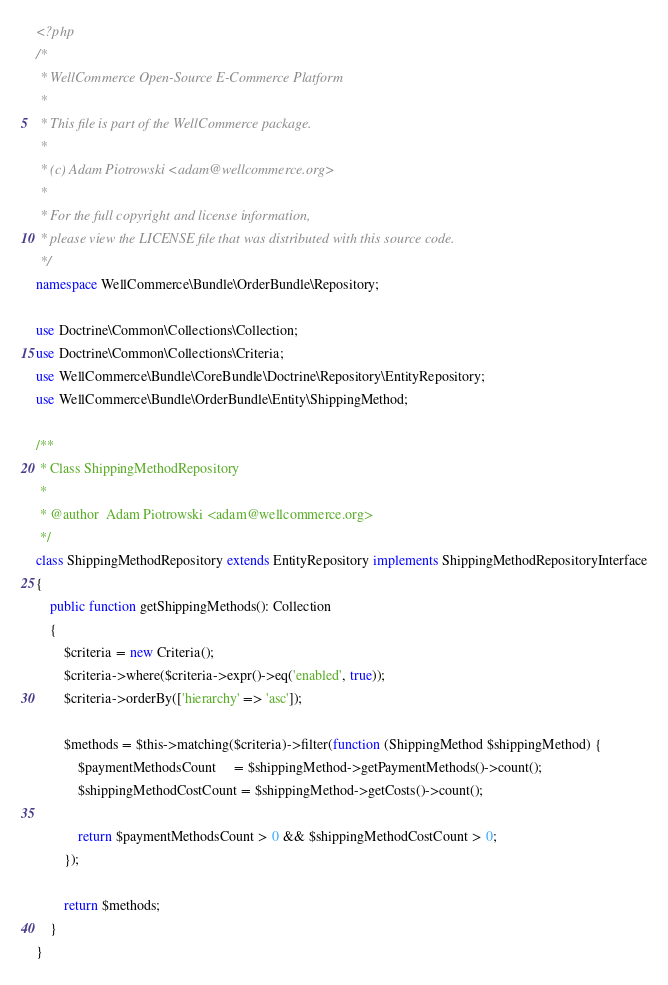<code> <loc_0><loc_0><loc_500><loc_500><_PHP_><?php
/*
 * WellCommerce Open-Source E-Commerce Platform
 *
 * This file is part of the WellCommerce package.
 *
 * (c) Adam Piotrowski <adam@wellcommerce.org>
 *
 * For the full copyright and license information,
 * please view the LICENSE file that was distributed with this source code.
 */
namespace WellCommerce\Bundle\OrderBundle\Repository;

use Doctrine\Common\Collections\Collection;
use Doctrine\Common\Collections\Criteria;
use WellCommerce\Bundle\CoreBundle\Doctrine\Repository\EntityRepository;
use WellCommerce\Bundle\OrderBundle\Entity\ShippingMethod;

/**
 * Class ShippingMethodRepository
 *
 * @author  Adam Piotrowski <adam@wellcommerce.org>
 */
class ShippingMethodRepository extends EntityRepository implements ShippingMethodRepositoryInterface
{
    public function getShippingMethods(): Collection
    {
        $criteria = new Criteria();
        $criteria->where($criteria->expr()->eq('enabled', true));
        $criteria->orderBy(['hierarchy' => 'asc']);
        
        $methods = $this->matching($criteria)->filter(function (ShippingMethod $shippingMethod) {
            $paymentMethodsCount     = $shippingMethod->getPaymentMethods()->count();
            $shippingMethodCostCount = $shippingMethod->getCosts()->count();
            
            return $paymentMethodsCount > 0 && $shippingMethodCostCount > 0;
        });
        
        return $methods;
    }
}
</code> 